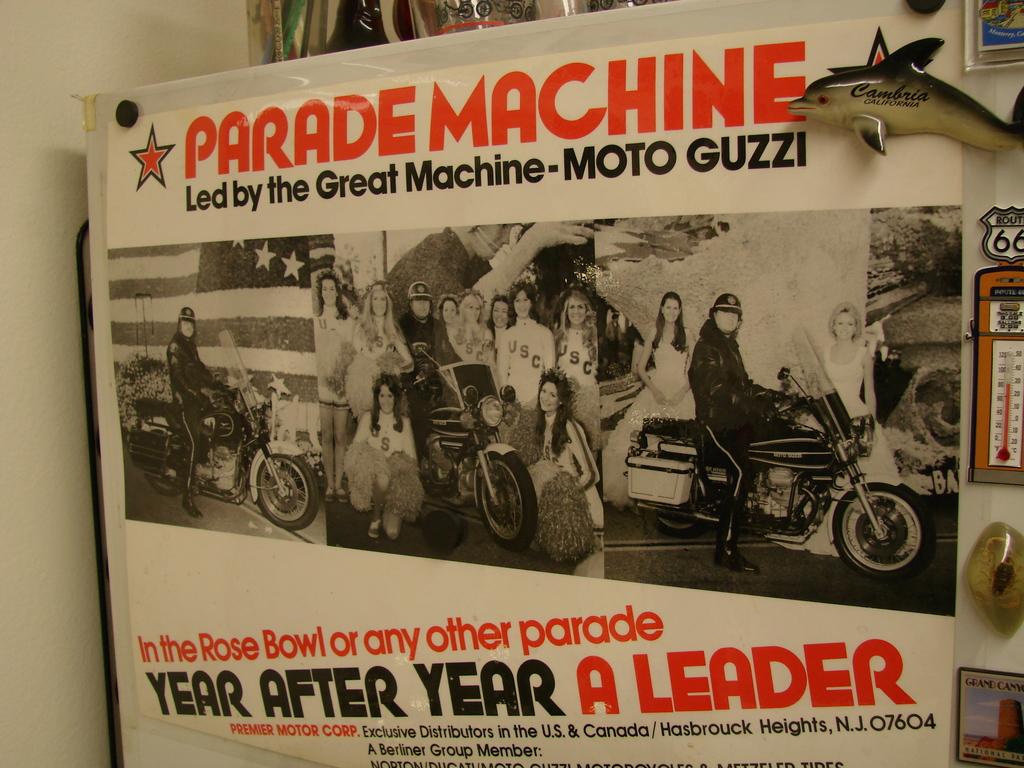What city is this?
Give a very brief answer. Hasbrouck heights. What is written in red on the top?
Your answer should be compact. Parade machine. 